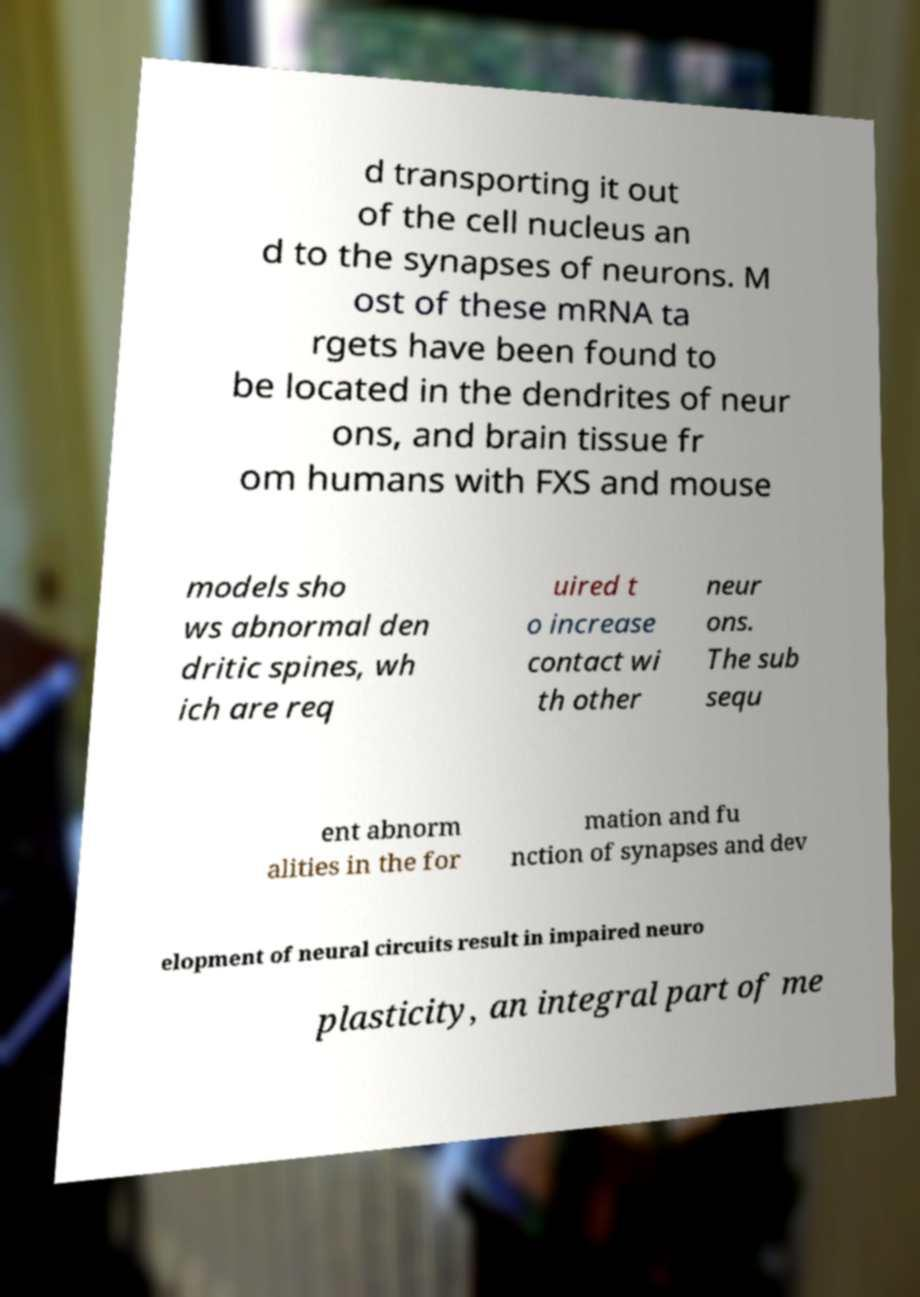What messages or text are displayed in this image? I need them in a readable, typed format. d transporting it out of the cell nucleus an d to the synapses of neurons. M ost of these mRNA ta rgets have been found to be located in the dendrites of neur ons, and brain tissue fr om humans with FXS and mouse models sho ws abnormal den dritic spines, wh ich are req uired t o increase contact wi th other neur ons. The sub sequ ent abnorm alities in the for mation and fu nction of synapses and dev elopment of neural circuits result in impaired neuro plasticity, an integral part of me 